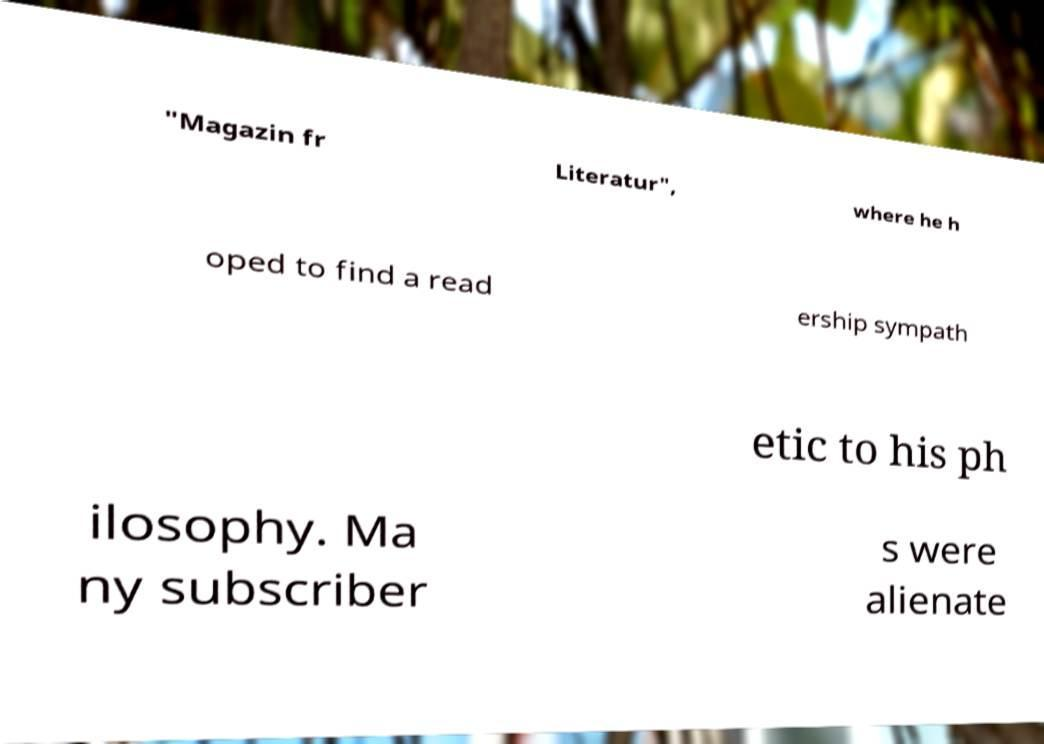What messages or text are displayed in this image? I need them in a readable, typed format. "Magazin fr Literatur", where he h oped to find a read ership sympath etic to his ph ilosophy. Ma ny subscriber s were alienate 